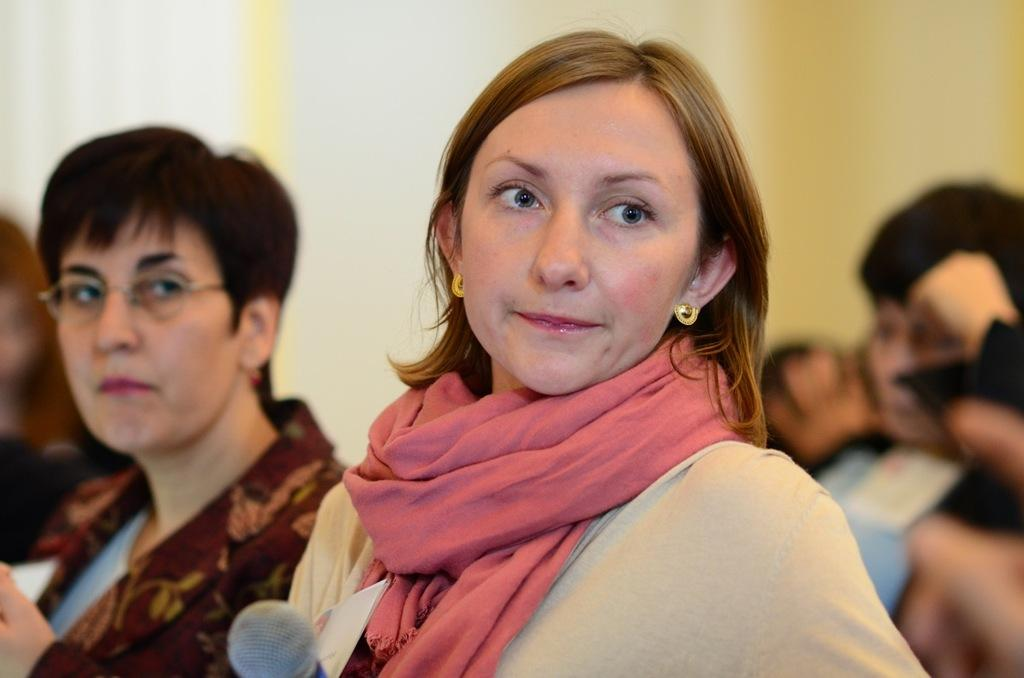How many people are in the image? There are a few people in the image. What object is located at the bottom of the image? There is a microphone at the bottom of the image. What can be seen behind the people and the microphone? The background of the image is visible. What type of marble can be seen near the ocean in the image? There is no marble or ocean present in the image. How does the temper of the people in the image affect their interactions? The temper of the people in the image cannot be determined from the image itself, as their emotions or attitudes are not visible. 